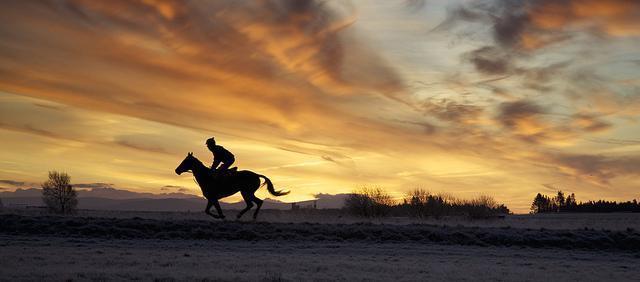How many real live dogs are in the photo?
Give a very brief answer. 0. 